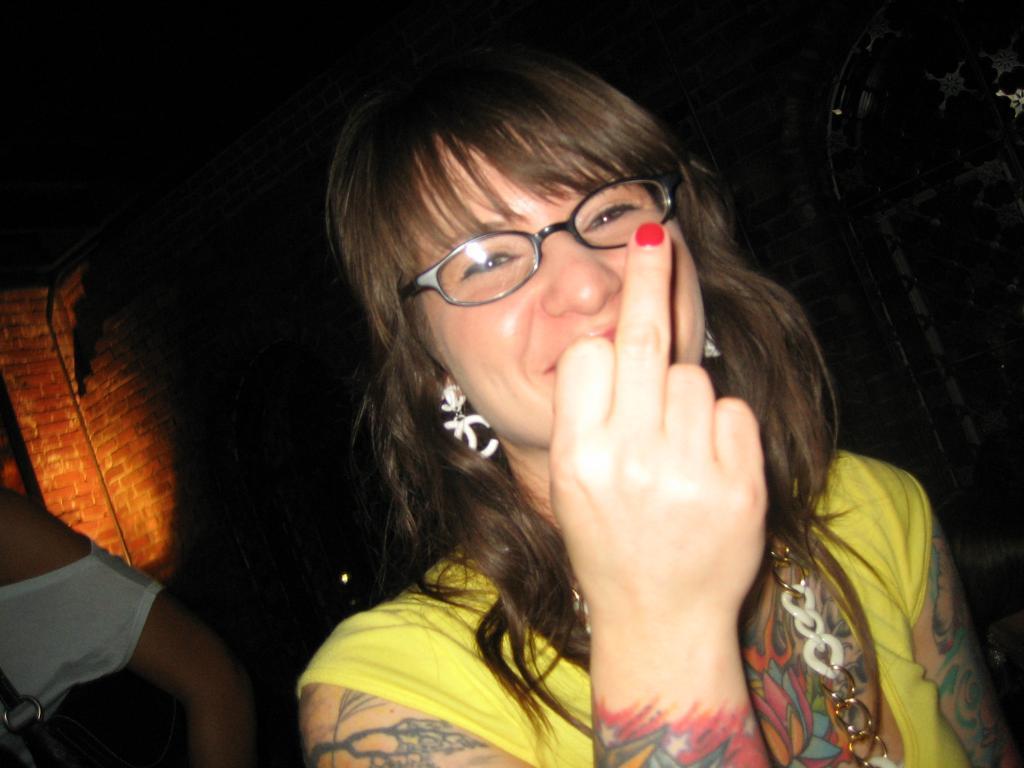Can you describe this image briefly? In the center of the image there is a woman wearing spectacles. In the background there is wall. 